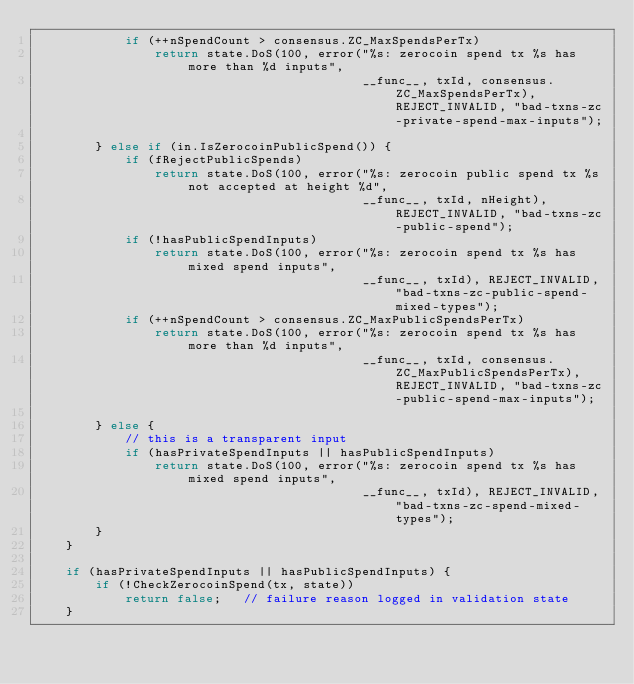<code> <loc_0><loc_0><loc_500><loc_500><_C++_>            if (++nSpendCount > consensus.ZC_MaxSpendsPerTx)
                return state.DoS(100, error("%s: zerocoin spend tx %s has more than %d inputs",
                                            __func__, txId, consensus.ZC_MaxSpendsPerTx), REJECT_INVALID, "bad-txns-zc-private-spend-max-inputs");

        } else if (in.IsZerocoinPublicSpend()) {
            if (fRejectPublicSpends)
                return state.DoS(100, error("%s: zerocoin public spend tx %s not accepted at height %d",
                                            __func__, txId, nHeight), REJECT_INVALID, "bad-txns-zc-public-spend");
            if (!hasPublicSpendInputs)
                return state.DoS(100, error("%s: zerocoin spend tx %s has mixed spend inputs",
                                            __func__, txId), REJECT_INVALID, "bad-txns-zc-public-spend-mixed-types");
            if (++nSpendCount > consensus.ZC_MaxPublicSpendsPerTx)
                return state.DoS(100, error("%s: zerocoin spend tx %s has more than %d inputs",
                                            __func__, txId, consensus.ZC_MaxPublicSpendsPerTx), REJECT_INVALID, "bad-txns-zc-public-spend-max-inputs");

        } else {
            // this is a transparent input
            if (hasPrivateSpendInputs || hasPublicSpendInputs)
                return state.DoS(100, error("%s: zerocoin spend tx %s has mixed spend inputs",
                                            __func__, txId), REJECT_INVALID, "bad-txns-zc-spend-mixed-types");
        }
    }

    if (hasPrivateSpendInputs || hasPublicSpendInputs) {
        if (!CheckZerocoinSpend(tx, state))
            return false;   // failure reason logged in validation state
    }
</code> 